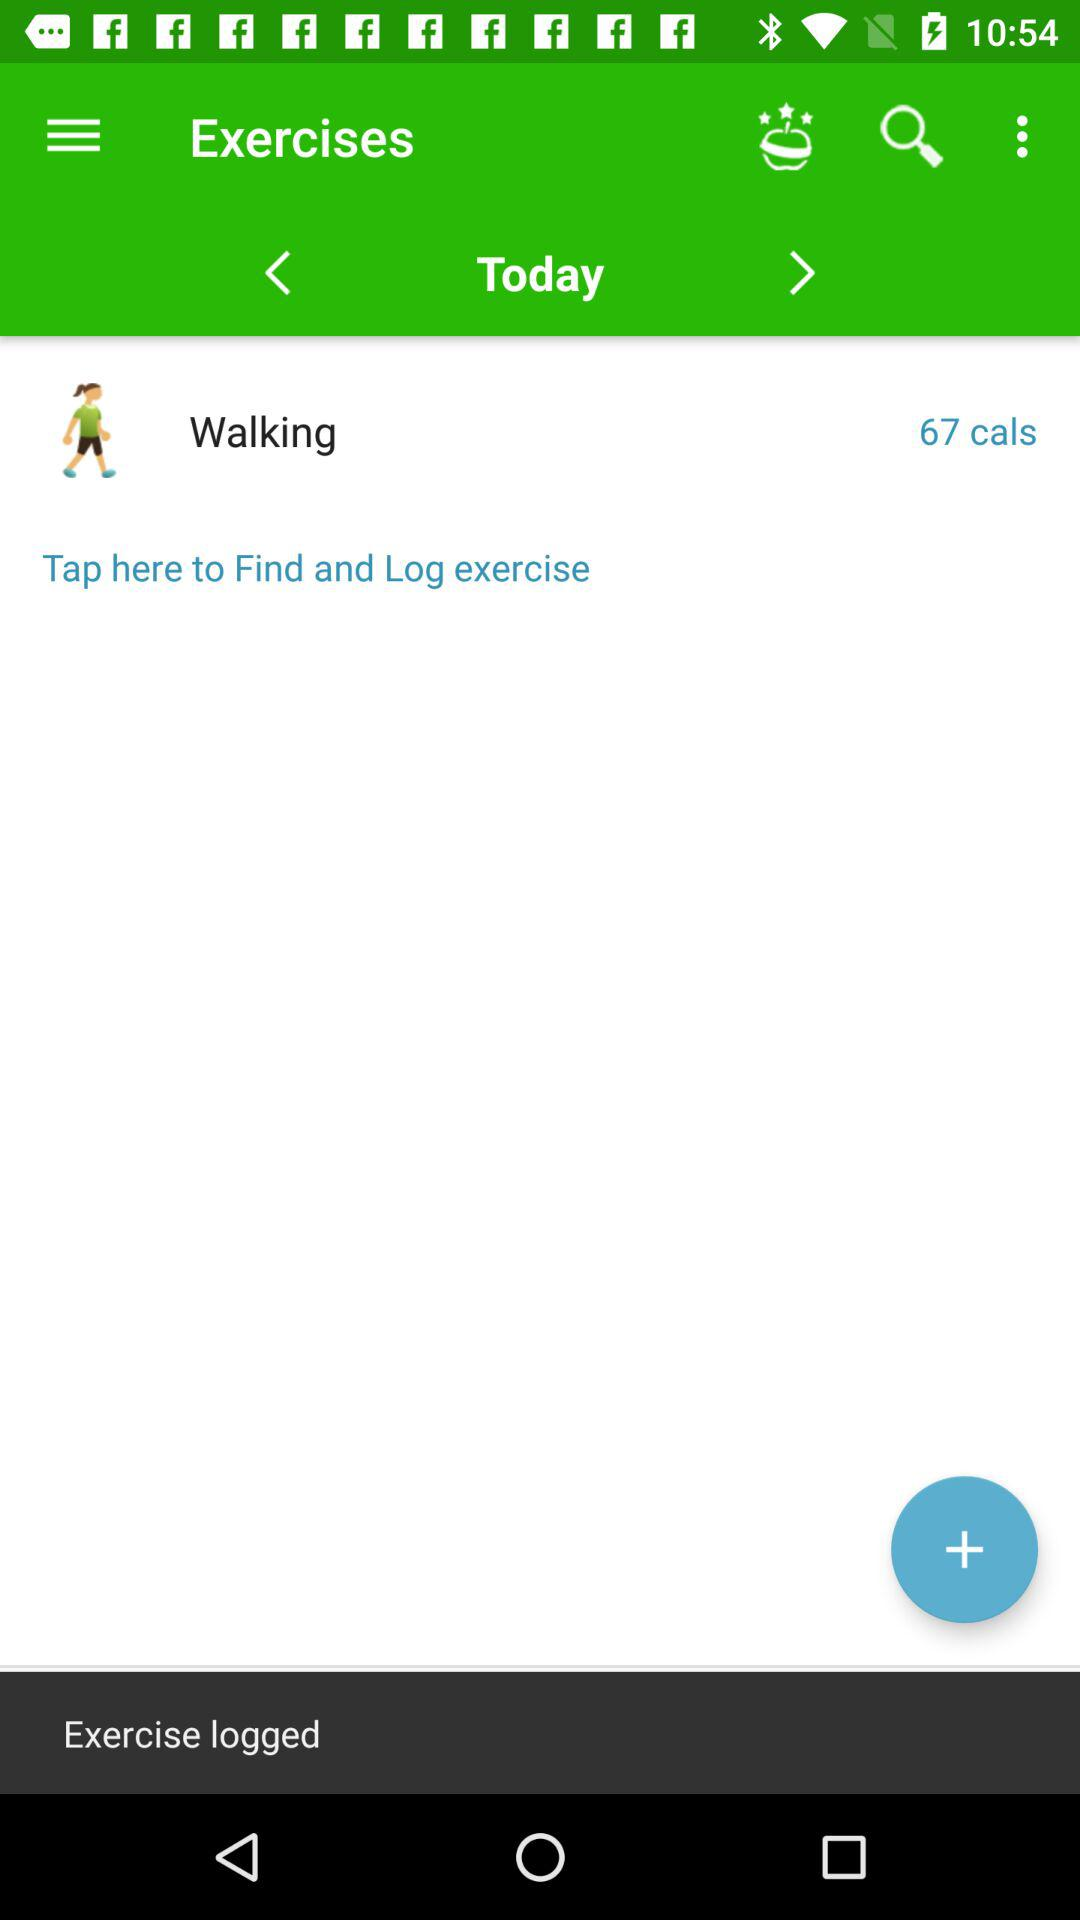How many calories are burned while walking? There are 67 calories burned while walking. 